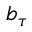<formula> <loc_0><loc_0><loc_500><loc_500>b _ { \tau }</formula> 